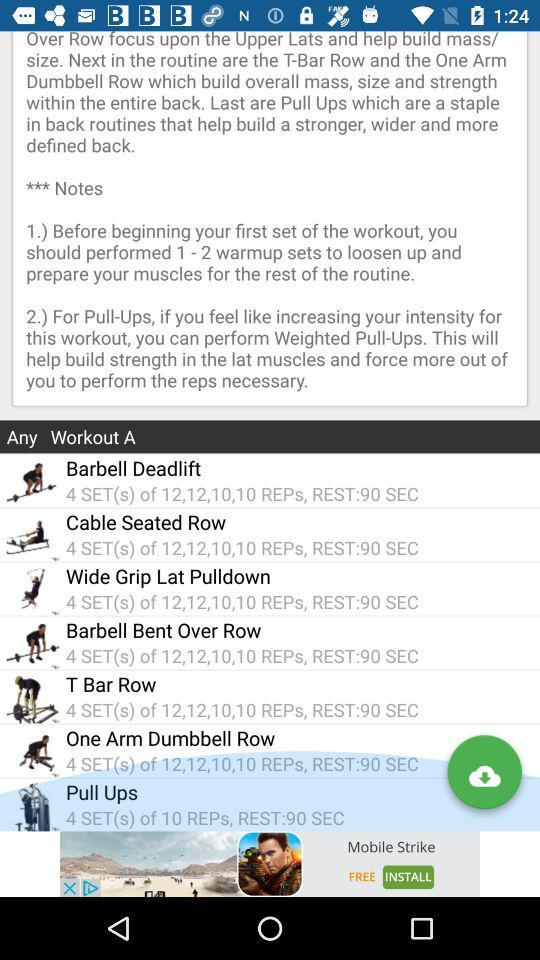How many reps in the cable seated row? The cable seated row consists of 4 SET(s) of 12,12,10,10. 